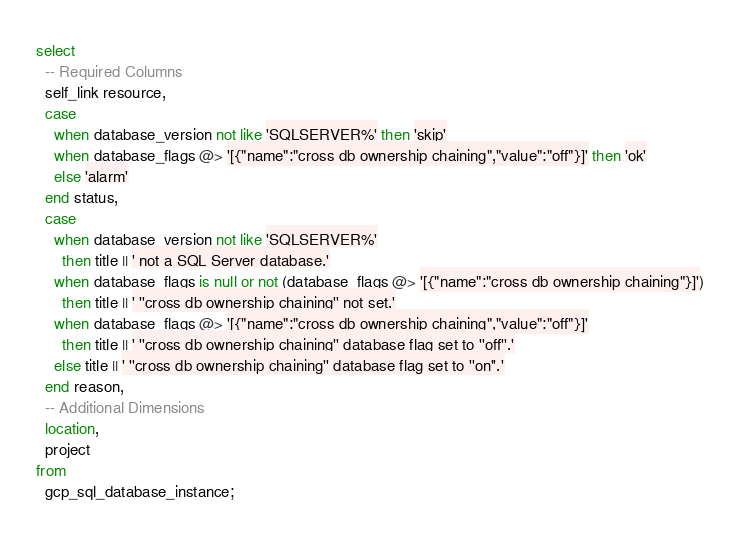Convert code to text. <code><loc_0><loc_0><loc_500><loc_500><_SQL_>select
  -- Required Columns
  self_link resource,
  case
    when database_version not like 'SQLSERVER%' then 'skip'
    when database_flags @> '[{"name":"cross db ownership chaining","value":"off"}]' then 'ok'
    else 'alarm'
  end status,
  case
    when database_version not like 'SQLSERVER%'
      then title || ' not a SQL Server database.'
    when database_flags is null or not (database_flags @> '[{"name":"cross db ownership chaining"}]')
      then title || ' ''cross db ownership chaining'' not set.'
    when database_flags @> '[{"name":"cross db ownership chaining","value":"off"}]'
      then title || ' ''cross db ownership chaining'' database flag set to ''off''.'
    else title || ' ''cross db ownership chaining'' database flag set to ''on''.'
  end reason,
  -- Additional Dimensions
  location,
  project
from
  gcp_sql_database_instance;</code> 